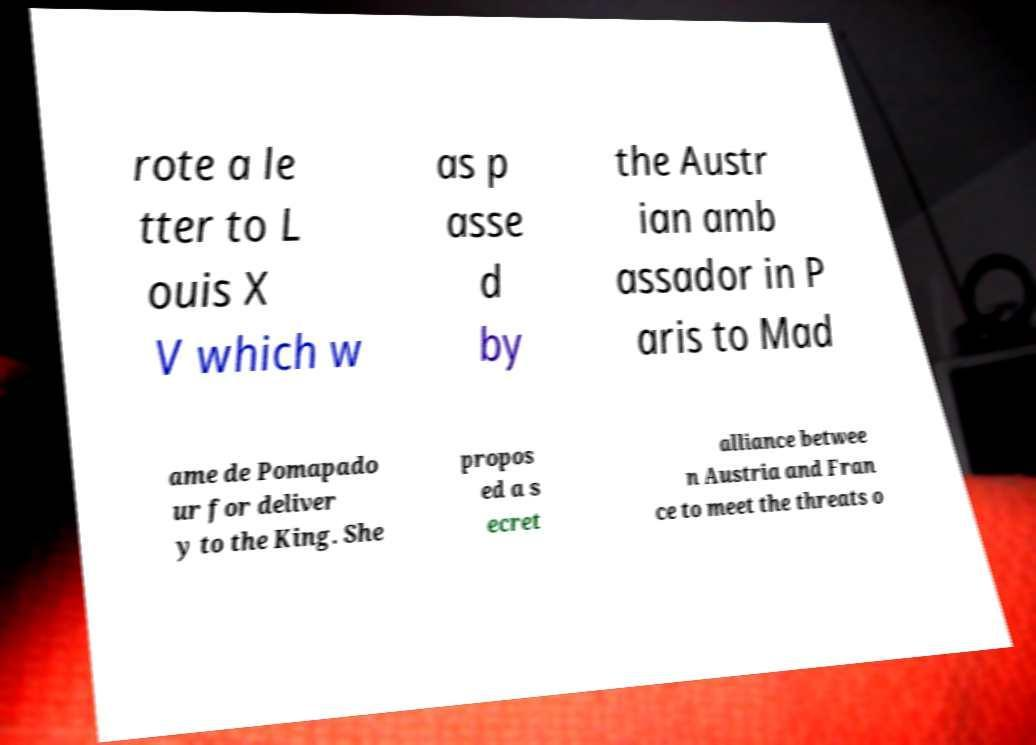There's text embedded in this image that I need extracted. Can you transcribe it verbatim? rote a le tter to L ouis X V which w as p asse d by the Austr ian amb assador in P aris to Mad ame de Pomapado ur for deliver y to the King. She propos ed a s ecret alliance betwee n Austria and Fran ce to meet the threats o 